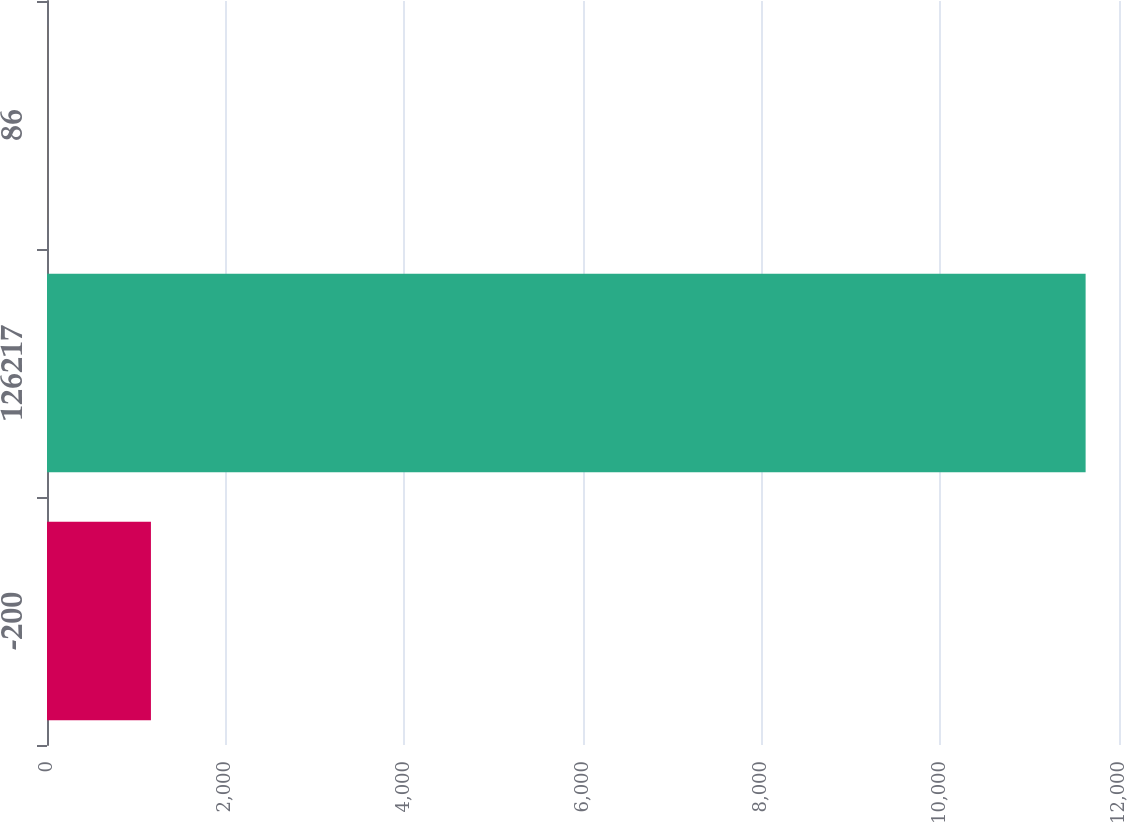<chart> <loc_0><loc_0><loc_500><loc_500><bar_chart><fcel>-200<fcel>126217<fcel>86<nl><fcel>1163.44<fcel>11626.3<fcel>0.9<nl></chart> 